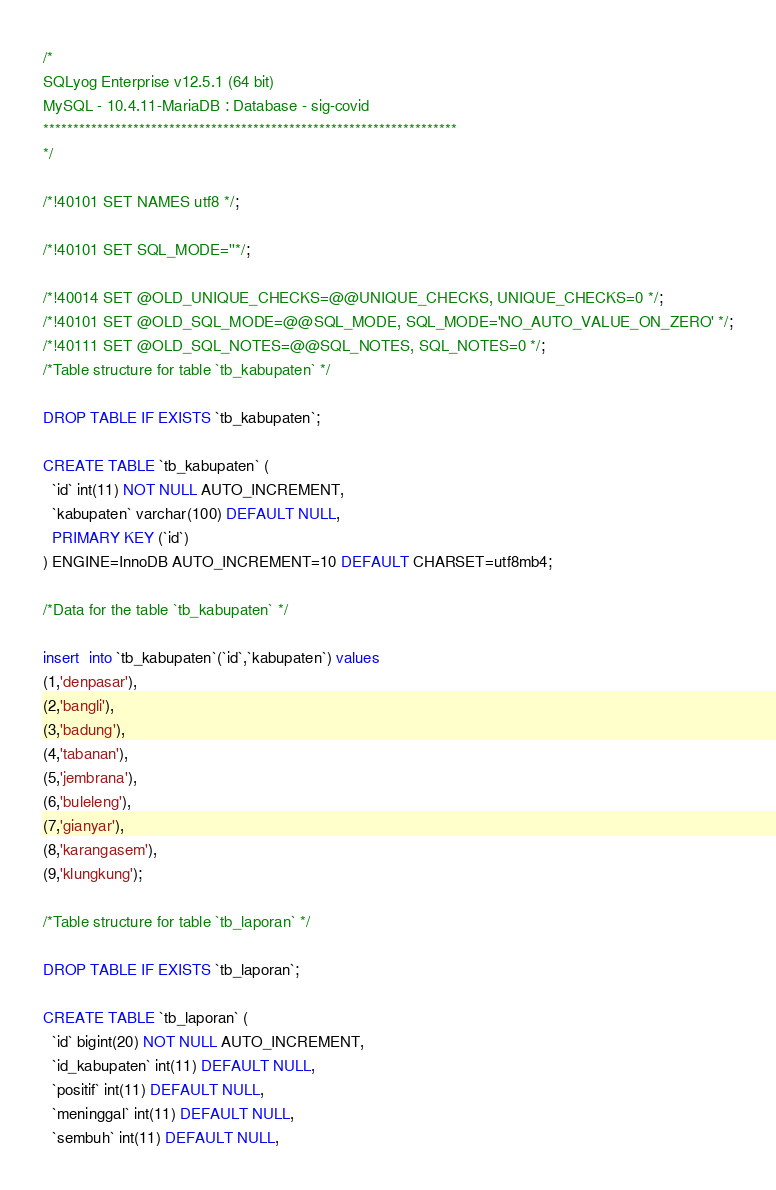<code> <loc_0><loc_0><loc_500><loc_500><_SQL_>/*
SQLyog Enterprise v12.5.1 (64 bit)
MySQL - 10.4.11-MariaDB : Database - sig-covid
*********************************************************************
*/

/*!40101 SET NAMES utf8 */;

/*!40101 SET SQL_MODE=''*/;

/*!40014 SET @OLD_UNIQUE_CHECKS=@@UNIQUE_CHECKS, UNIQUE_CHECKS=0 */;
/*!40101 SET @OLD_SQL_MODE=@@SQL_MODE, SQL_MODE='NO_AUTO_VALUE_ON_ZERO' */;
/*!40111 SET @OLD_SQL_NOTES=@@SQL_NOTES, SQL_NOTES=0 */;
/*Table structure for table `tb_kabupaten` */

DROP TABLE IF EXISTS `tb_kabupaten`;

CREATE TABLE `tb_kabupaten` (
  `id` int(11) NOT NULL AUTO_INCREMENT,
  `kabupaten` varchar(100) DEFAULT NULL,
  PRIMARY KEY (`id`)
) ENGINE=InnoDB AUTO_INCREMENT=10 DEFAULT CHARSET=utf8mb4;

/*Data for the table `tb_kabupaten` */

insert  into `tb_kabupaten`(`id`,`kabupaten`) values 
(1,'denpasar'),
(2,'bangli'),
(3,'badung'),
(4,'tabanan'),
(5,'jembrana'),
(6,'buleleng'),
(7,'gianyar'),
(8,'karangasem'),
(9,'klungkung');

/*Table structure for table `tb_laporan` */

DROP TABLE IF EXISTS `tb_laporan`;

CREATE TABLE `tb_laporan` (
  `id` bigint(20) NOT NULL AUTO_INCREMENT,
  `id_kabupaten` int(11) DEFAULT NULL,
  `positif` int(11) DEFAULT NULL,
  `meninggal` int(11) DEFAULT NULL,
  `sembuh` int(11) DEFAULT NULL,</code> 